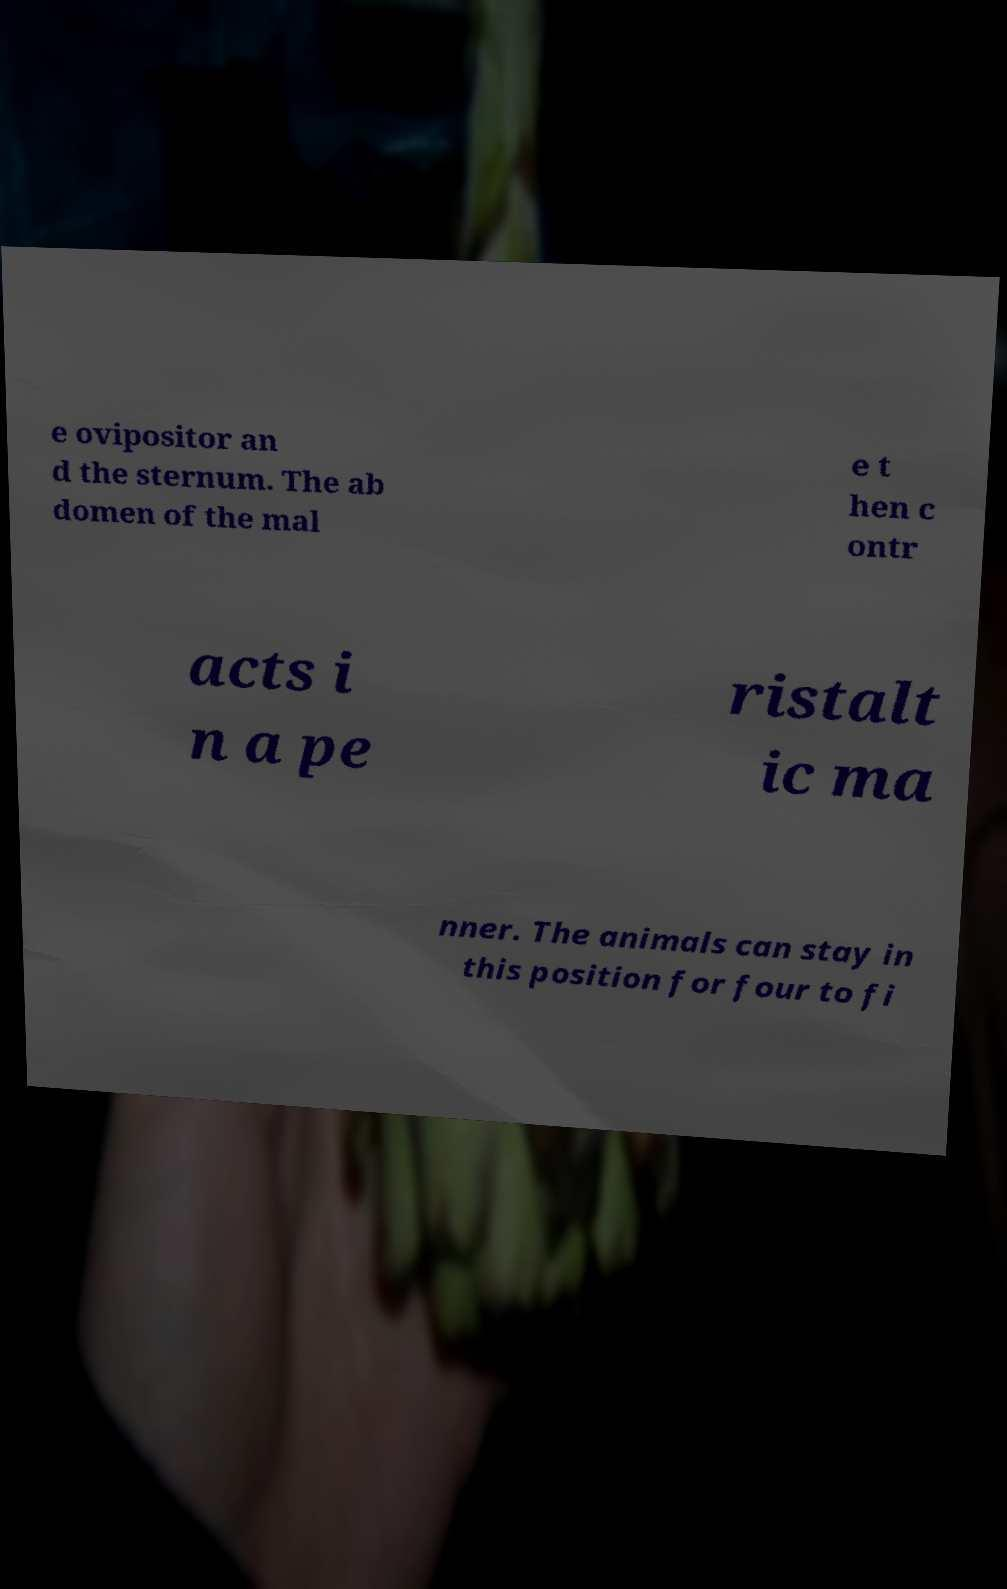Can you read and provide the text displayed in the image?This photo seems to have some interesting text. Can you extract and type it out for me? e ovipositor an d the sternum. The ab domen of the mal e t hen c ontr acts i n a pe ristalt ic ma nner. The animals can stay in this position for four to fi 